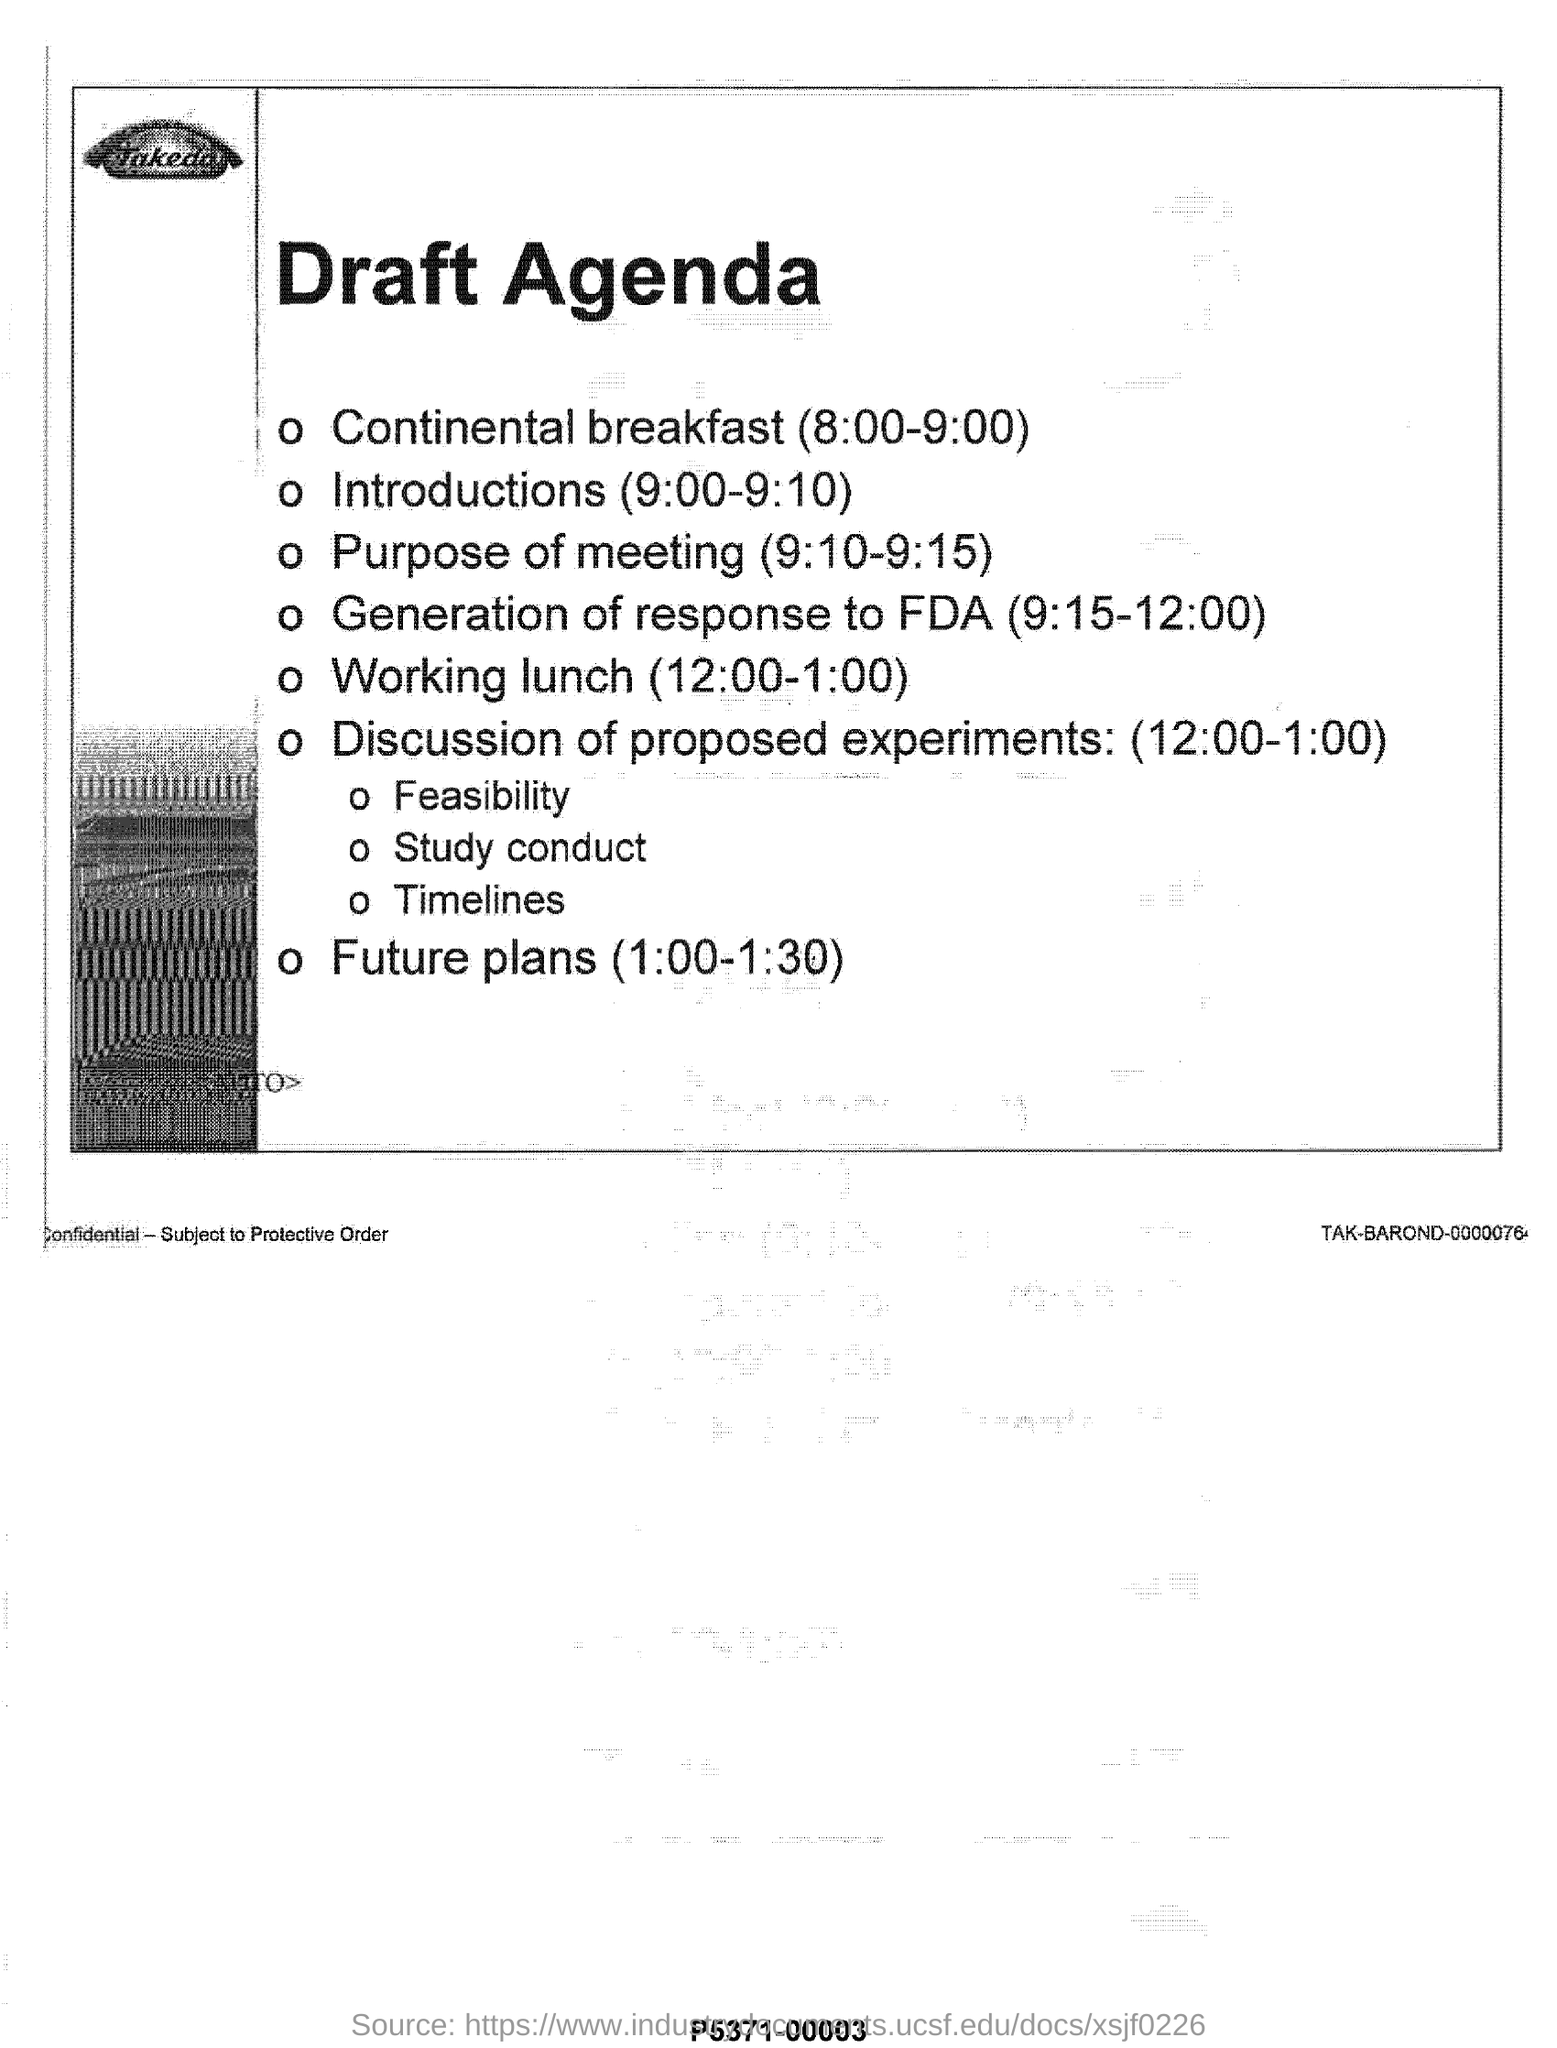Heading of the document?
Your answer should be very brief. Draft Agenda. What are the timings for Continental Breakfast?
Ensure brevity in your answer.  8:00-9:00. 